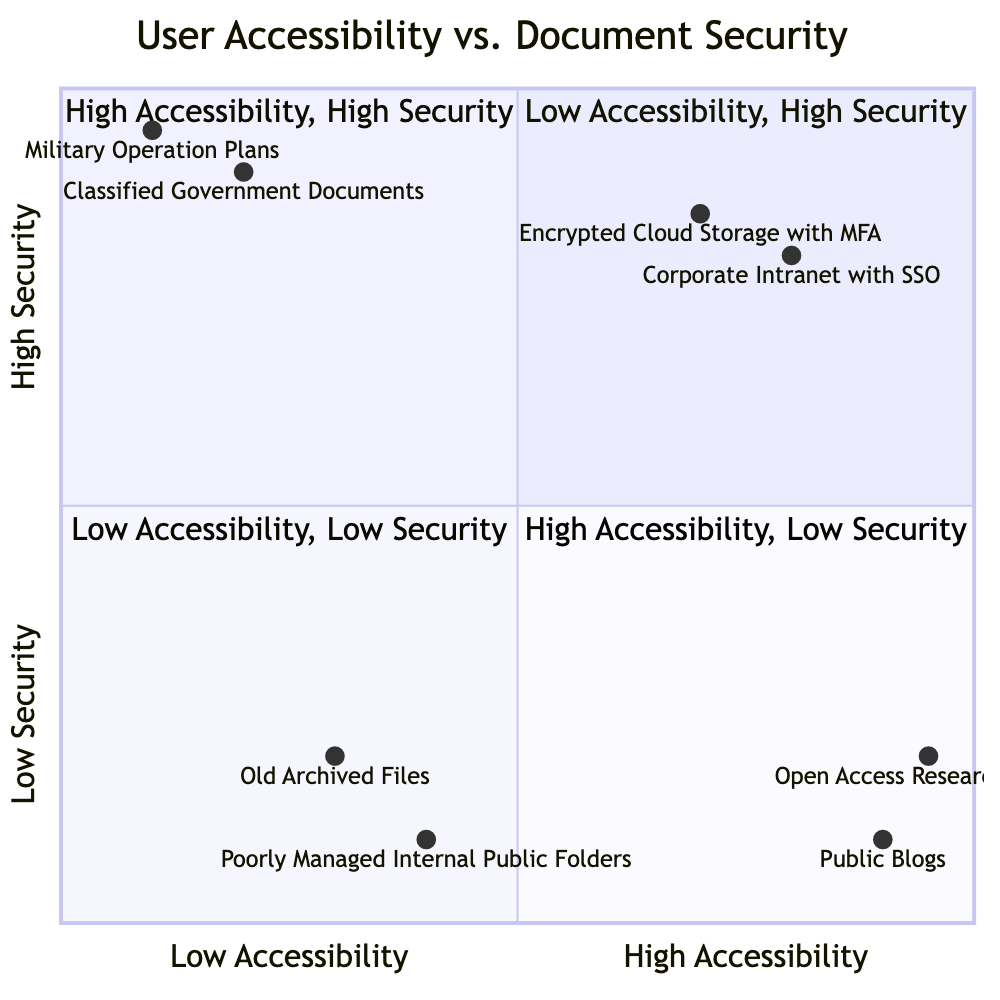What documents fall under the "High Accessibility, Low Security" quadrant? The quadrant named "High Accessibility, Low Security" is described to include easily accessible documents with minimal security. Based on the examples given, the documents that classify in this quadrant are "Public Blogs" and "Open Access Research Papers."
Answer: Public Blogs, Open Access Research Papers Which quadrant contains "Classified Government Documents"? The "Classified Government Documents" is specified in the diagram to fall within the "Low Accessibility, High Security" quadrant. This quadrant is for documents that are highly secure but difficult to access.
Answer: Low Accessibility, High Security How many documents are in the "Low Accessibility, Low Security" quadrant? In the "Low Accessibility, Low Security" quadrant, there are two examples provided: "Old Archived Files with No Encryption" and "Poorly Managed Internal Public Folders." Thus, the count of documents in this quadrant is two.
Answer: 2 What is the security level of the "Corporate Intranet with SSO"? The document "Corporate Intranet with SSO" is plotted at the coordinates [0.8, 0.8]. The y-coordinate (which represents security measures) has a value of 0.8, indicating a high security level.
Answer: 0.8 What is the relationship between accessibility and security in the "High Accessibility, High Security" quadrant? The "High Accessibility, High Security" quadrant indicates a positive relationship where documents are both easy to access and have strong security measures. This balance implies that security does not overly compromise accessibility.
Answer: Positive relationship Which security level corresponds to "Old Archived Files"? "Old Archived Files" is positioned at the coordinates [0.3, 0.2]. The y-coordinate (indicating security measures) is 0.2, showing a low security level.
Answer: 0.2 Which quadrant includes documents with both high accessibility and high security? The quadrant labeled "High Accessibility, High Security" includes documents that maintain a balance of accessibility and security.
Answer: High Accessibility, High Security What examples illustrate the "Low Accessibility, High Security" quadrant? The examples given for the "Low Accessibility, High Security" quadrant are "Classified Government Documents" and "Military Operation Plans," both of which provide strong security but are hard to access.
Answer: Classified Government Documents, Military Operation Plans 